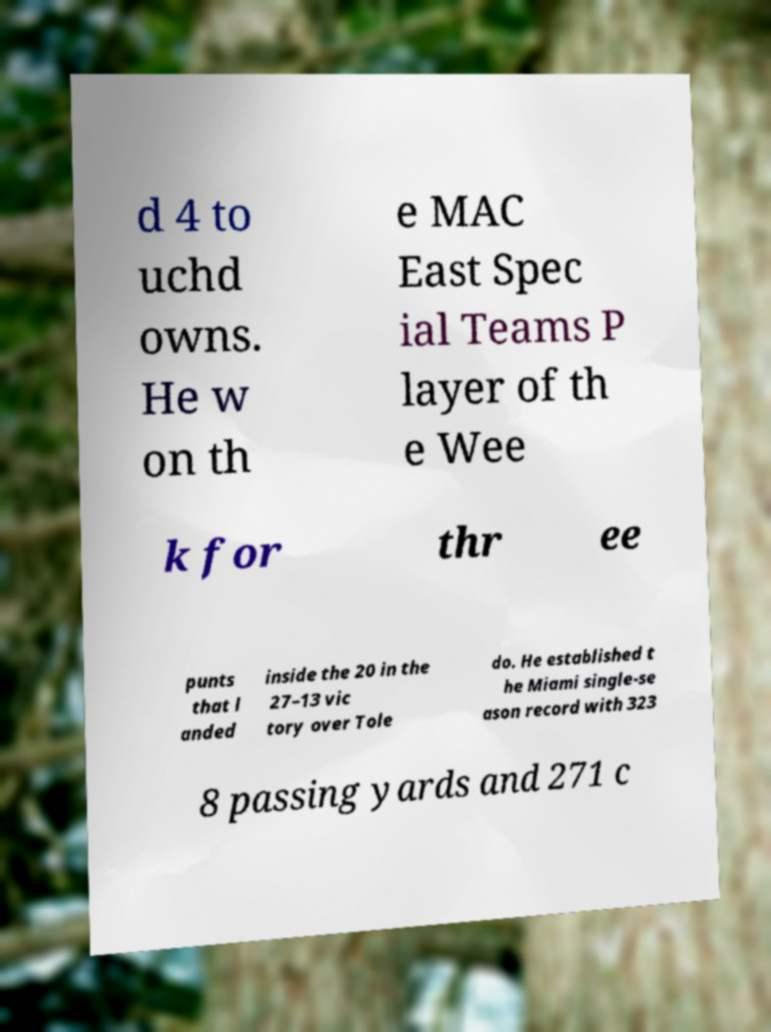Could you assist in decoding the text presented in this image and type it out clearly? d 4 to uchd owns. He w on th e MAC East Spec ial Teams P layer of th e Wee k for thr ee punts that l anded inside the 20 in the 27–13 vic tory over Tole do. He established t he Miami single-se ason record with 323 8 passing yards and 271 c 